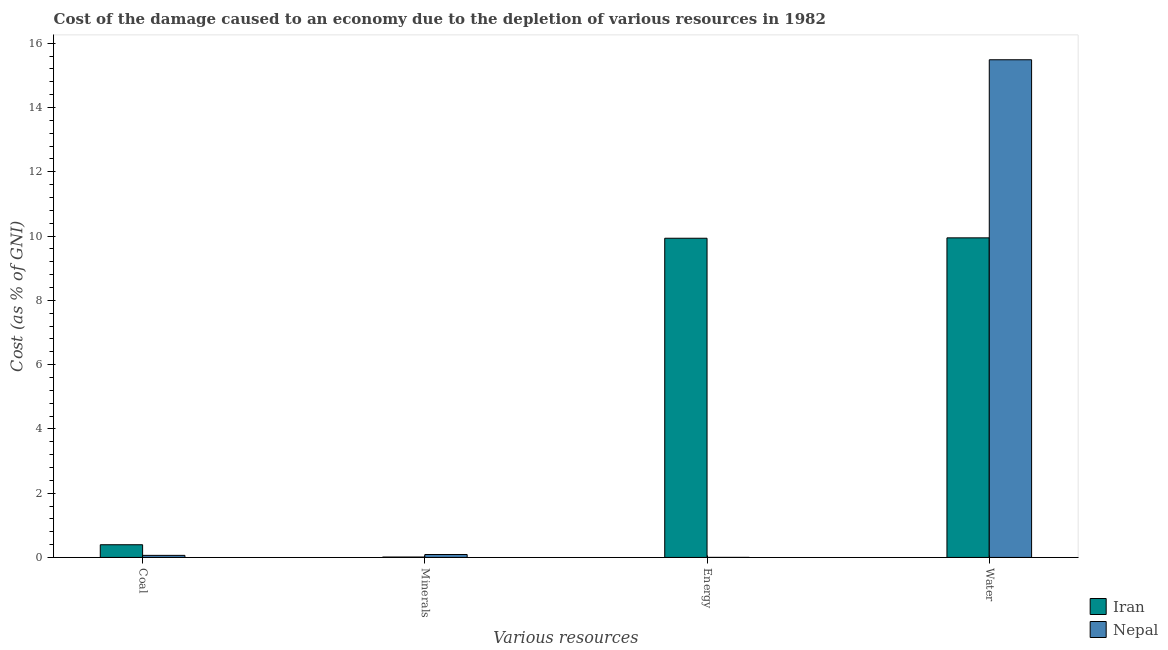Are the number of bars on each tick of the X-axis equal?
Provide a short and direct response. Yes. How many bars are there on the 1st tick from the left?
Offer a very short reply. 2. What is the label of the 4th group of bars from the left?
Make the answer very short. Water. What is the cost of damage due to depletion of energy in Iran?
Keep it short and to the point. 9.93. Across all countries, what is the maximum cost of damage due to depletion of energy?
Offer a very short reply. 9.93. Across all countries, what is the minimum cost of damage due to depletion of water?
Offer a terse response. 9.94. In which country was the cost of damage due to depletion of water maximum?
Your response must be concise. Nepal. In which country was the cost of damage due to depletion of minerals minimum?
Your response must be concise. Iran. What is the total cost of damage due to depletion of coal in the graph?
Your answer should be very brief. 0.46. What is the difference between the cost of damage due to depletion of water in Iran and that in Nepal?
Offer a very short reply. -5.54. What is the difference between the cost of damage due to depletion of coal in Iran and the cost of damage due to depletion of energy in Nepal?
Your answer should be compact. 0.39. What is the average cost of damage due to depletion of water per country?
Keep it short and to the point. 12.72. What is the difference between the cost of damage due to depletion of water and cost of damage due to depletion of energy in Nepal?
Keep it short and to the point. 15.49. In how many countries, is the cost of damage due to depletion of minerals greater than 6 %?
Offer a terse response. 0. What is the ratio of the cost of damage due to depletion of water in Nepal to that in Iran?
Give a very brief answer. 1.56. Is the cost of damage due to depletion of water in Iran less than that in Nepal?
Make the answer very short. Yes. Is the difference between the cost of damage due to depletion of water in Nepal and Iran greater than the difference between the cost of damage due to depletion of energy in Nepal and Iran?
Offer a terse response. Yes. What is the difference between the highest and the second highest cost of damage due to depletion of water?
Make the answer very short. 5.54. What is the difference between the highest and the lowest cost of damage due to depletion of coal?
Keep it short and to the point. 0.33. Is the sum of the cost of damage due to depletion of coal in Nepal and Iran greater than the maximum cost of damage due to depletion of energy across all countries?
Provide a short and direct response. No. Is it the case that in every country, the sum of the cost of damage due to depletion of coal and cost of damage due to depletion of water is greater than the sum of cost of damage due to depletion of energy and cost of damage due to depletion of minerals?
Your answer should be compact. Yes. What does the 1st bar from the left in Water represents?
Provide a succinct answer. Iran. What does the 1st bar from the right in Water represents?
Provide a short and direct response. Nepal. Is it the case that in every country, the sum of the cost of damage due to depletion of coal and cost of damage due to depletion of minerals is greater than the cost of damage due to depletion of energy?
Provide a succinct answer. No. How many bars are there?
Provide a succinct answer. 8. How many countries are there in the graph?
Give a very brief answer. 2. What is the difference between two consecutive major ticks on the Y-axis?
Offer a terse response. 2. Does the graph contain any zero values?
Ensure brevity in your answer.  No. Where does the legend appear in the graph?
Offer a very short reply. Bottom right. How are the legend labels stacked?
Offer a terse response. Vertical. What is the title of the graph?
Ensure brevity in your answer.  Cost of the damage caused to an economy due to the depletion of various resources in 1982 . What is the label or title of the X-axis?
Provide a succinct answer. Various resources. What is the label or title of the Y-axis?
Provide a short and direct response. Cost (as % of GNI). What is the Cost (as % of GNI) of Iran in Coal?
Keep it short and to the point. 0.39. What is the Cost (as % of GNI) of Nepal in Coal?
Offer a very short reply. 0.06. What is the Cost (as % of GNI) of Iran in Minerals?
Offer a terse response. 0.01. What is the Cost (as % of GNI) of Nepal in Minerals?
Ensure brevity in your answer.  0.09. What is the Cost (as % of GNI) of Iran in Energy?
Ensure brevity in your answer.  9.93. What is the Cost (as % of GNI) in Nepal in Energy?
Your answer should be compact. 0. What is the Cost (as % of GNI) of Iran in Water?
Make the answer very short. 9.94. What is the Cost (as % of GNI) of Nepal in Water?
Make the answer very short. 15.49. Across all Various resources, what is the maximum Cost (as % of GNI) in Iran?
Provide a short and direct response. 9.94. Across all Various resources, what is the maximum Cost (as % of GNI) of Nepal?
Your response must be concise. 15.49. Across all Various resources, what is the minimum Cost (as % of GNI) of Iran?
Ensure brevity in your answer.  0.01. Across all Various resources, what is the minimum Cost (as % of GNI) in Nepal?
Provide a short and direct response. 0. What is the total Cost (as % of GNI) in Iran in the graph?
Keep it short and to the point. 20.28. What is the total Cost (as % of GNI) in Nepal in the graph?
Provide a succinct answer. 15.64. What is the difference between the Cost (as % of GNI) of Iran in Coal and that in Minerals?
Ensure brevity in your answer.  0.38. What is the difference between the Cost (as % of GNI) of Nepal in Coal and that in Minerals?
Offer a terse response. -0.03. What is the difference between the Cost (as % of GNI) of Iran in Coal and that in Energy?
Your answer should be very brief. -9.54. What is the difference between the Cost (as % of GNI) of Nepal in Coal and that in Energy?
Keep it short and to the point. 0.06. What is the difference between the Cost (as % of GNI) of Iran in Coal and that in Water?
Your answer should be compact. -9.55. What is the difference between the Cost (as % of GNI) in Nepal in Coal and that in Water?
Your answer should be compact. -15.42. What is the difference between the Cost (as % of GNI) of Iran in Minerals and that in Energy?
Give a very brief answer. -9.92. What is the difference between the Cost (as % of GNI) in Nepal in Minerals and that in Energy?
Provide a succinct answer. 0.09. What is the difference between the Cost (as % of GNI) of Iran in Minerals and that in Water?
Provide a short and direct response. -9.93. What is the difference between the Cost (as % of GNI) in Nepal in Minerals and that in Water?
Keep it short and to the point. -15.4. What is the difference between the Cost (as % of GNI) in Iran in Energy and that in Water?
Keep it short and to the point. -0.01. What is the difference between the Cost (as % of GNI) of Nepal in Energy and that in Water?
Keep it short and to the point. -15.49. What is the difference between the Cost (as % of GNI) in Iran in Coal and the Cost (as % of GNI) in Nepal in Minerals?
Offer a terse response. 0.3. What is the difference between the Cost (as % of GNI) of Iran in Coal and the Cost (as % of GNI) of Nepal in Energy?
Keep it short and to the point. 0.39. What is the difference between the Cost (as % of GNI) in Iran in Coal and the Cost (as % of GNI) in Nepal in Water?
Give a very brief answer. -15.09. What is the difference between the Cost (as % of GNI) in Iran in Minerals and the Cost (as % of GNI) in Nepal in Energy?
Offer a very short reply. 0.01. What is the difference between the Cost (as % of GNI) of Iran in Minerals and the Cost (as % of GNI) of Nepal in Water?
Provide a short and direct response. -15.47. What is the difference between the Cost (as % of GNI) of Iran in Energy and the Cost (as % of GNI) of Nepal in Water?
Give a very brief answer. -5.55. What is the average Cost (as % of GNI) of Iran per Various resources?
Provide a succinct answer. 5.07. What is the average Cost (as % of GNI) in Nepal per Various resources?
Your answer should be compact. 3.91. What is the difference between the Cost (as % of GNI) in Iran and Cost (as % of GNI) in Nepal in Coal?
Ensure brevity in your answer.  0.33. What is the difference between the Cost (as % of GNI) of Iran and Cost (as % of GNI) of Nepal in Minerals?
Ensure brevity in your answer.  -0.08. What is the difference between the Cost (as % of GNI) in Iran and Cost (as % of GNI) in Nepal in Energy?
Ensure brevity in your answer.  9.93. What is the difference between the Cost (as % of GNI) in Iran and Cost (as % of GNI) in Nepal in Water?
Offer a very short reply. -5.54. What is the ratio of the Cost (as % of GNI) of Iran in Coal to that in Minerals?
Provide a succinct answer. 32.41. What is the ratio of the Cost (as % of GNI) of Nepal in Coal to that in Minerals?
Offer a very short reply. 0.71. What is the ratio of the Cost (as % of GNI) in Iran in Coal to that in Energy?
Your answer should be compact. 0.04. What is the ratio of the Cost (as % of GNI) in Nepal in Coal to that in Energy?
Your answer should be compact. 44.25. What is the ratio of the Cost (as % of GNI) of Iran in Coal to that in Water?
Make the answer very short. 0.04. What is the ratio of the Cost (as % of GNI) of Nepal in Coal to that in Water?
Offer a very short reply. 0. What is the ratio of the Cost (as % of GNI) in Iran in Minerals to that in Energy?
Your response must be concise. 0. What is the ratio of the Cost (as % of GNI) of Nepal in Minerals to that in Energy?
Ensure brevity in your answer.  62.66. What is the ratio of the Cost (as % of GNI) in Iran in Minerals to that in Water?
Make the answer very short. 0. What is the ratio of the Cost (as % of GNI) in Nepal in Minerals to that in Water?
Give a very brief answer. 0.01. What is the ratio of the Cost (as % of GNI) in Iran in Energy to that in Water?
Your answer should be compact. 1. What is the ratio of the Cost (as % of GNI) in Nepal in Energy to that in Water?
Keep it short and to the point. 0. What is the difference between the highest and the second highest Cost (as % of GNI) of Iran?
Your response must be concise. 0.01. What is the difference between the highest and the second highest Cost (as % of GNI) in Nepal?
Your response must be concise. 15.4. What is the difference between the highest and the lowest Cost (as % of GNI) of Iran?
Offer a terse response. 9.93. What is the difference between the highest and the lowest Cost (as % of GNI) of Nepal?
Provide a short and direct response. 15.49. 